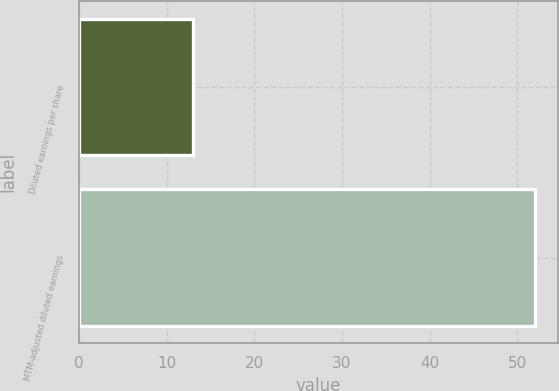<chart> <loc_0><loc_0><loc_500><loc_500><bar_chart><fcel>Diluted earnings per share<fcel>MTM-adjusted diluted earnings<nl><fcel>13<fcel>52<nl></chart> 